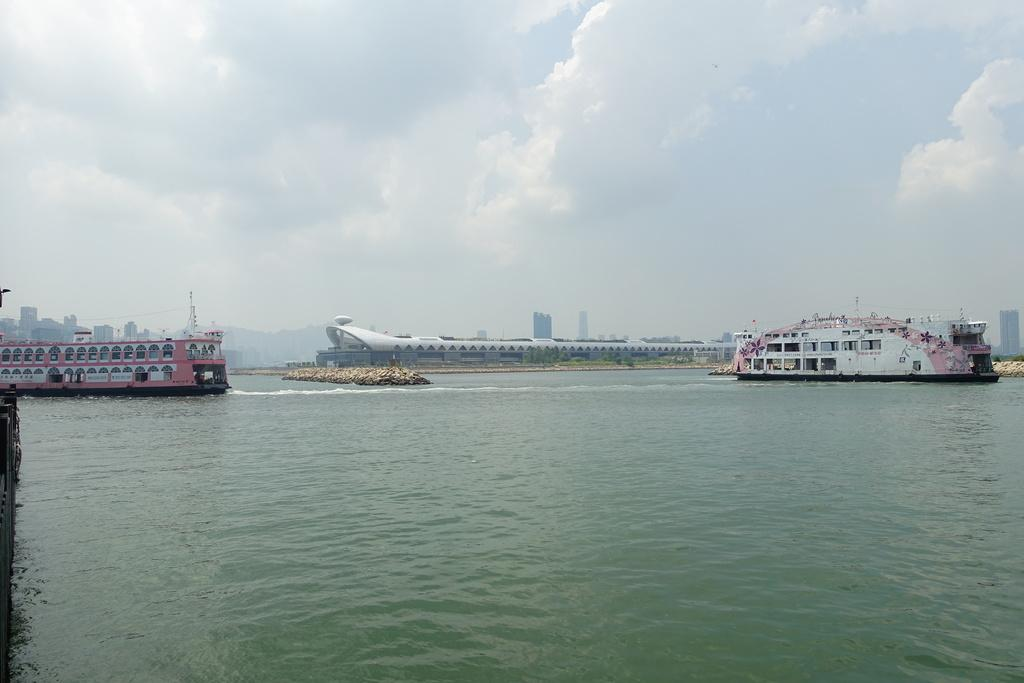What can be seen in the image that is related to transportation? There are two ships in the image. What is the ships' location in relation to the water? The ships are floating on water. What type of water body is present in the image? There is a river in the middle of the image. What can be seen in the sky in the background of the image? There are clouds in the sky in the background of the image. What type of sack is being used to carry the quarter in the image? There is no sack or quarter present in the image. How is the string tied to the ship in the image? There is no string tied to the ship in the image. 